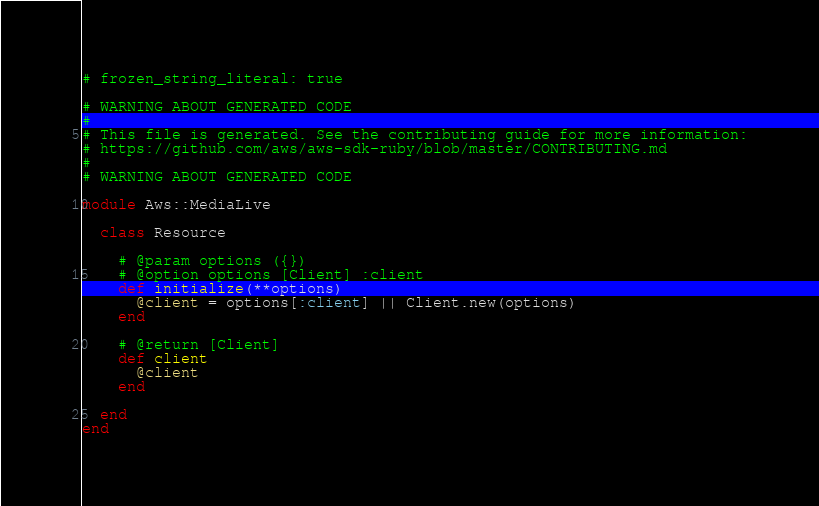<code> <loc_0><loc_0><loc_500><loc_500><_Crystal_># frozen_string_literal: true

# WARNING ABOUT GENERATED CODE
#
# This file is generated. See the contributing guide for more information:
# https://github.com/aws/aws-sdk-ruby/blob/master/CONTRIBUTING.md
#
# WARNING ABOUT GENERATED CODE

module Aws::MediaLive

  class Resource

    # @param options ({})
    # @option options [Client] :client
    def initialize(**options)
      @client = options[:client] || Client.new(options)
    end

    # @return [Client]
    def client
      @client
    end

  end
end
</code> 